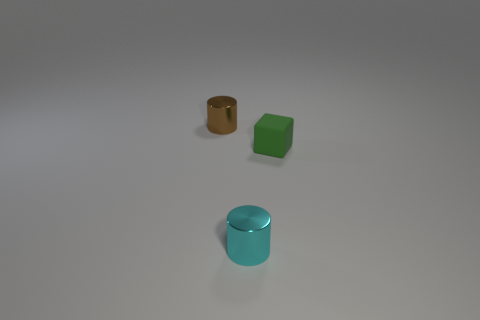Does the tiny thing that is left of the small cyan cylinder have the same material as the tiny object that is right of the cyan metal cylinder?
Make the answer very short. No. What is the size of the shiny thing that is in front of the tiny cylinder behind the tiny cube?
Make the answer very short. Small. There is another tiny object that is the same shape as the brown object; what is its material?
Your response must be concise. Metal. Do the small shiny thing on the right side of the brown metallic thing and the shiny thing left of the cyan metallic object have the same shape?
Your answer should be very brief. Yes. Are there more matte blocks than purple matte cylinders?
Ensure brevity in your answer.  Yes. Does the cylinder that is in front of the cube have the same material as the tiny block?
Make the answer very short. No. Are there fewer cyan cylinders behind the small cyan thing than tiny cylinders that are behind the small rubber block?
Keep it short and to the point. Yes. What number of other things are the same material as the green cube?
Make the answer very short. 0. There is a green cube that is the same size as the cyan cylinder; what is its material?
Your answer should be compact. Rubber. Is the number of tiny green blocks that are behind the small cube less than the number of cubes?
Offer a very short reply. Yes. 